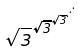Convert formula to latex. <formula><loc_0><loc_0><loc_500><loc_500>\sqrt { 3 } ^ { \sqrt { 3 } ^ { \sqrt { 3 } ^ { \cdot ^ { \cdot ^ { \cdot } } } } }</formula> 